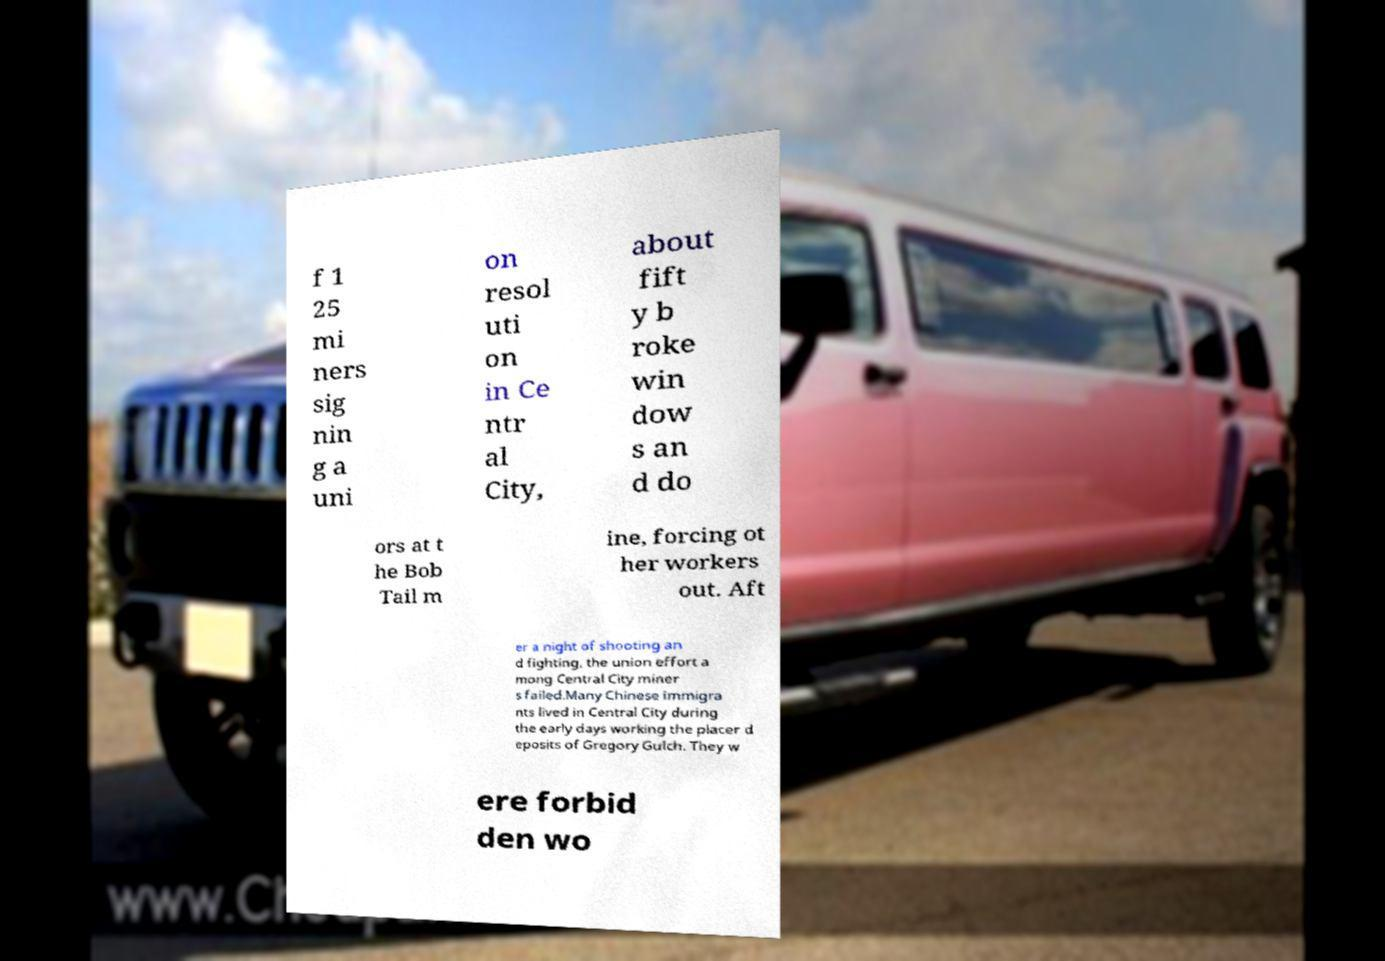I need the written content from this picture converted into text. Can you do that? f 1 25 mi ners sig nin g a uni on resol uti on in Ce ntr al City, about fift y b roke win dow s an d do ors at t he Bob Tail m ine, forcing ot her workers out. Aft er a night of shooting an d fighting, the union effort a mong Central City miner s failed.Many Chinese immigra nts lived in Central City during the early days working the placer d eposits of Gregory Gulch. They w ere forbid den wo 